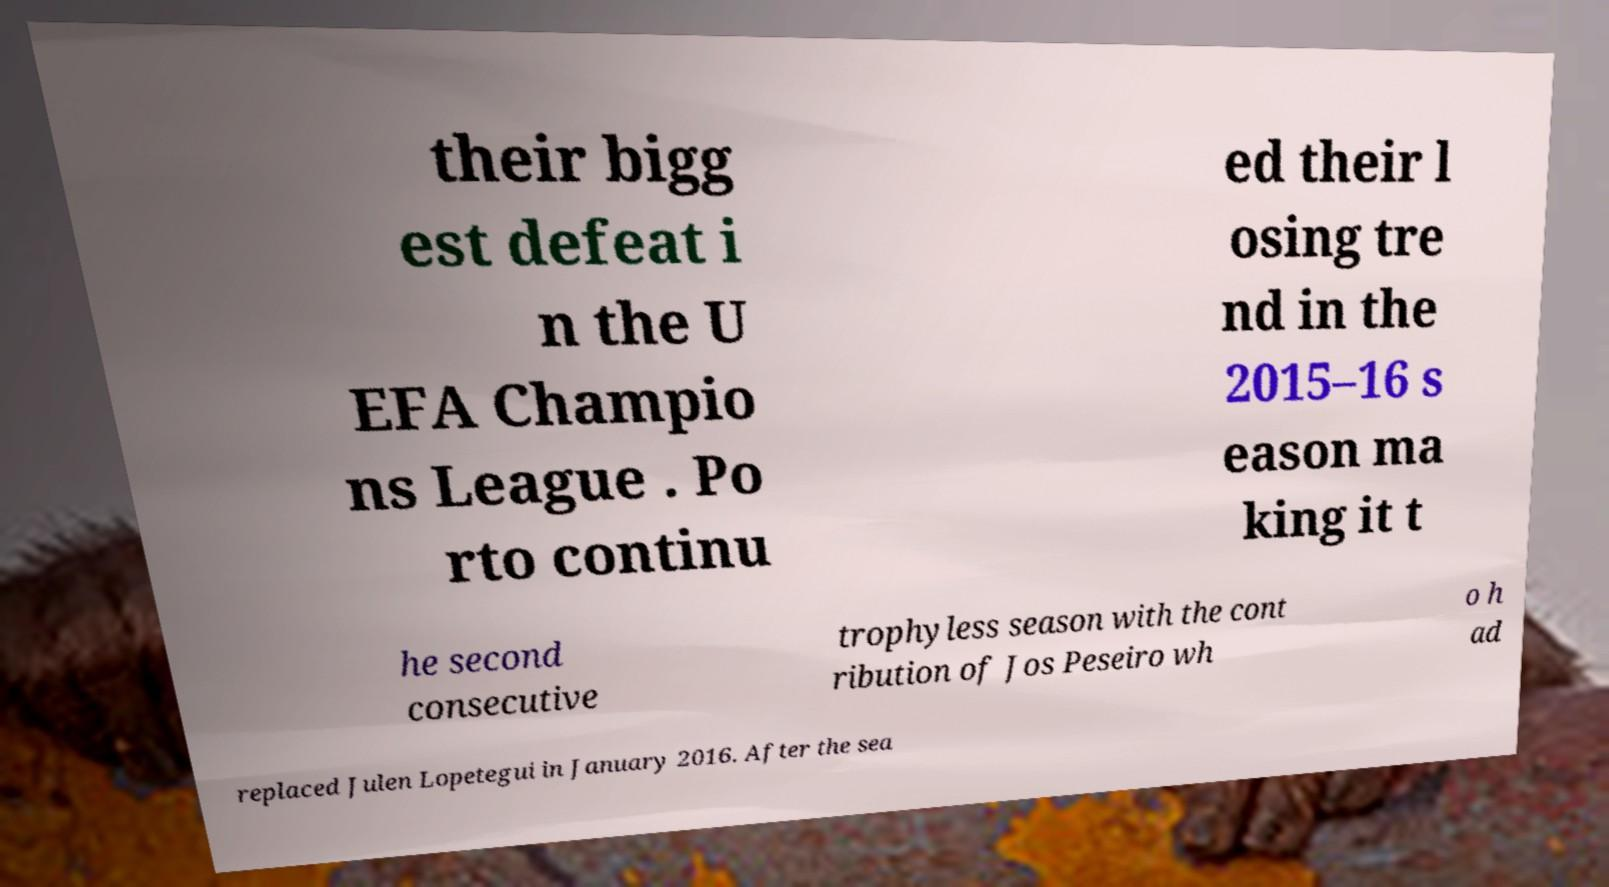Please read and relay the text visible in this image. What does it say? their bigg est defeat i n the U EFA Champio ns League . Po rto continu ed their l osing tre nd in the 2015–16 s eason ma king it t he second consecutive trophyless season with the cont ribution of Jos Peseiro wh o h ad replaced Julen Lopetegui in January 2016. After the sea 